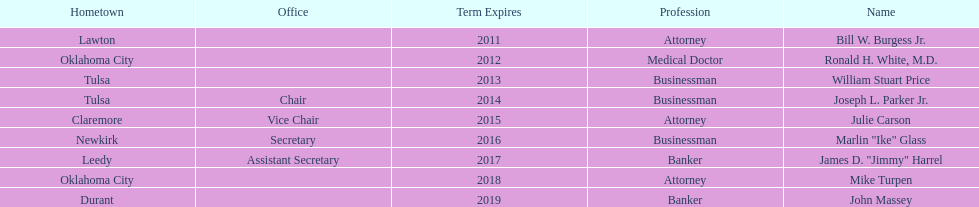How many members had business owner listed as their career? 3. 